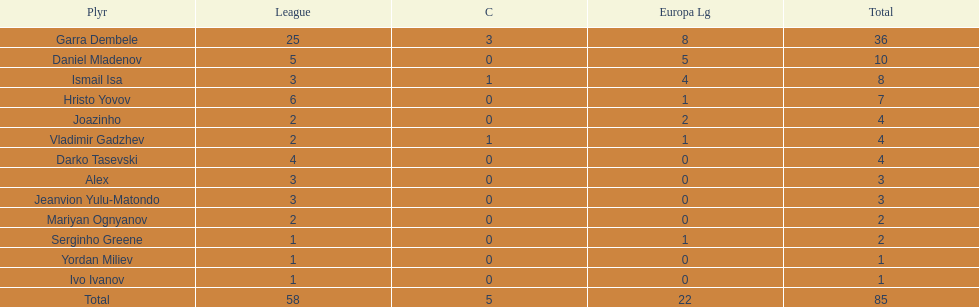Who had the most goal scores? Garra Dembele. Parse the table in full. {'header': ['Plyr', 'League', 'C', 'Europa Lg', 'Total'], 'rows': [['Garra Dembele', '25', '3', '8', '36'], ['Daniel Mladenov', '5', '0', '5', '10'], ['Ismail Isa', '3', '1', '4', '8'], ['Hristo Yovov', '6', '0', '1', '7'], ['Joazinho', '2', '0', '2', '4'], ['Vladimir Gadzhev', '2', '1', '1', '4'], ['Darko Tasevski', '4', '0', '0', '4'], ['Alex', '3', '0', '0', '3'], ['Jeanvion Yulu-Matondo', '3', '0', '0', '3'], ['Mariyan Ognyanov', '2', '0', '0', '2'], ['Serginho Greene', '1', '0', '1', '2'], ['Yordan Miliev', '1', '0', '0', '1'], ['Ivo Ivanov', '1', '0', '0', '1'], ['Total', '58', '5', '22', '85']]} 